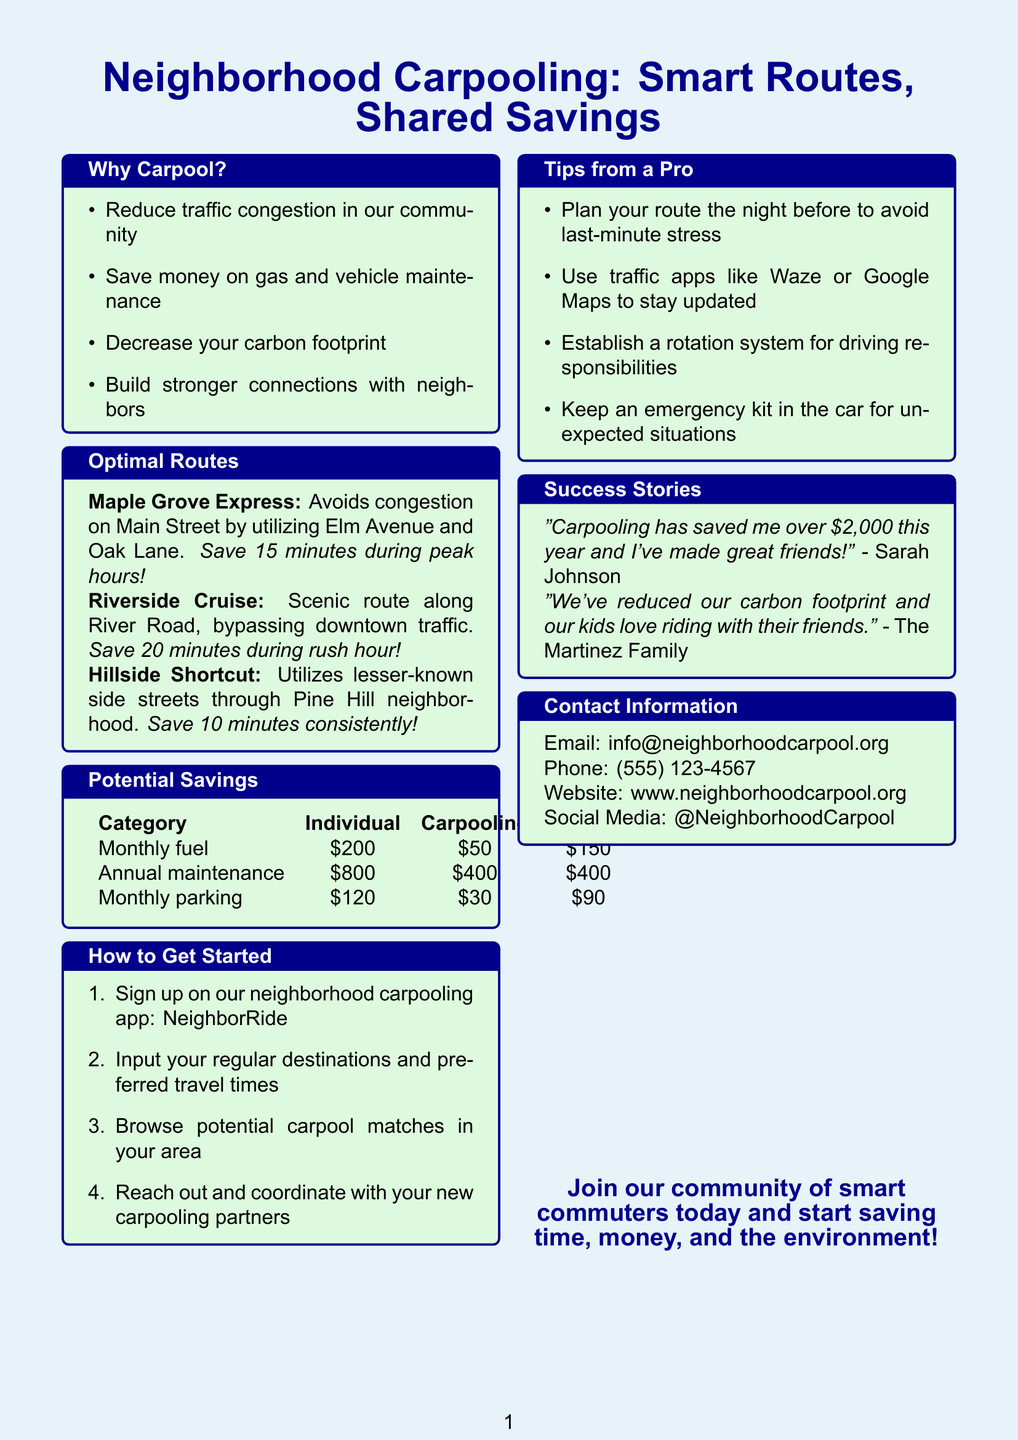What is the title of the brochure? The title is prominently displayed at the top of the brochure.
Answer: Neighborhood Carpooling: Smart Routes, Shared Savings How many optimal routes are listed in the brochure? The brochure provides information about three specific routes.
Answer: Three What is the estimated time saved by using the Riverside Cruise route? The document specifies the time saved for this route during rush hour.
Answer: 20 minutes What is the monthly fuel cost for individuals before carpooling? The brochure lists the individual costs under potential savings.
Answer: $200 What is the savings from annual vehicle maintenance when carpooling? The savings are highlighted in the potential savings section of the brochure.
Answer: $400 What app should you sign up for to get started in carpooling? The document mentions the app to facilitate joining the carpooling initiative.
Answer: NeighborRide What is one tip mentioned for planning your route? The brochure includes professional tips for effective route planning.
Answer: Plan your route the night before What did Sarah Johnson save through carpooling this year? The quote provided in the success stories section gives this specific figure.
Answer: $2,000 